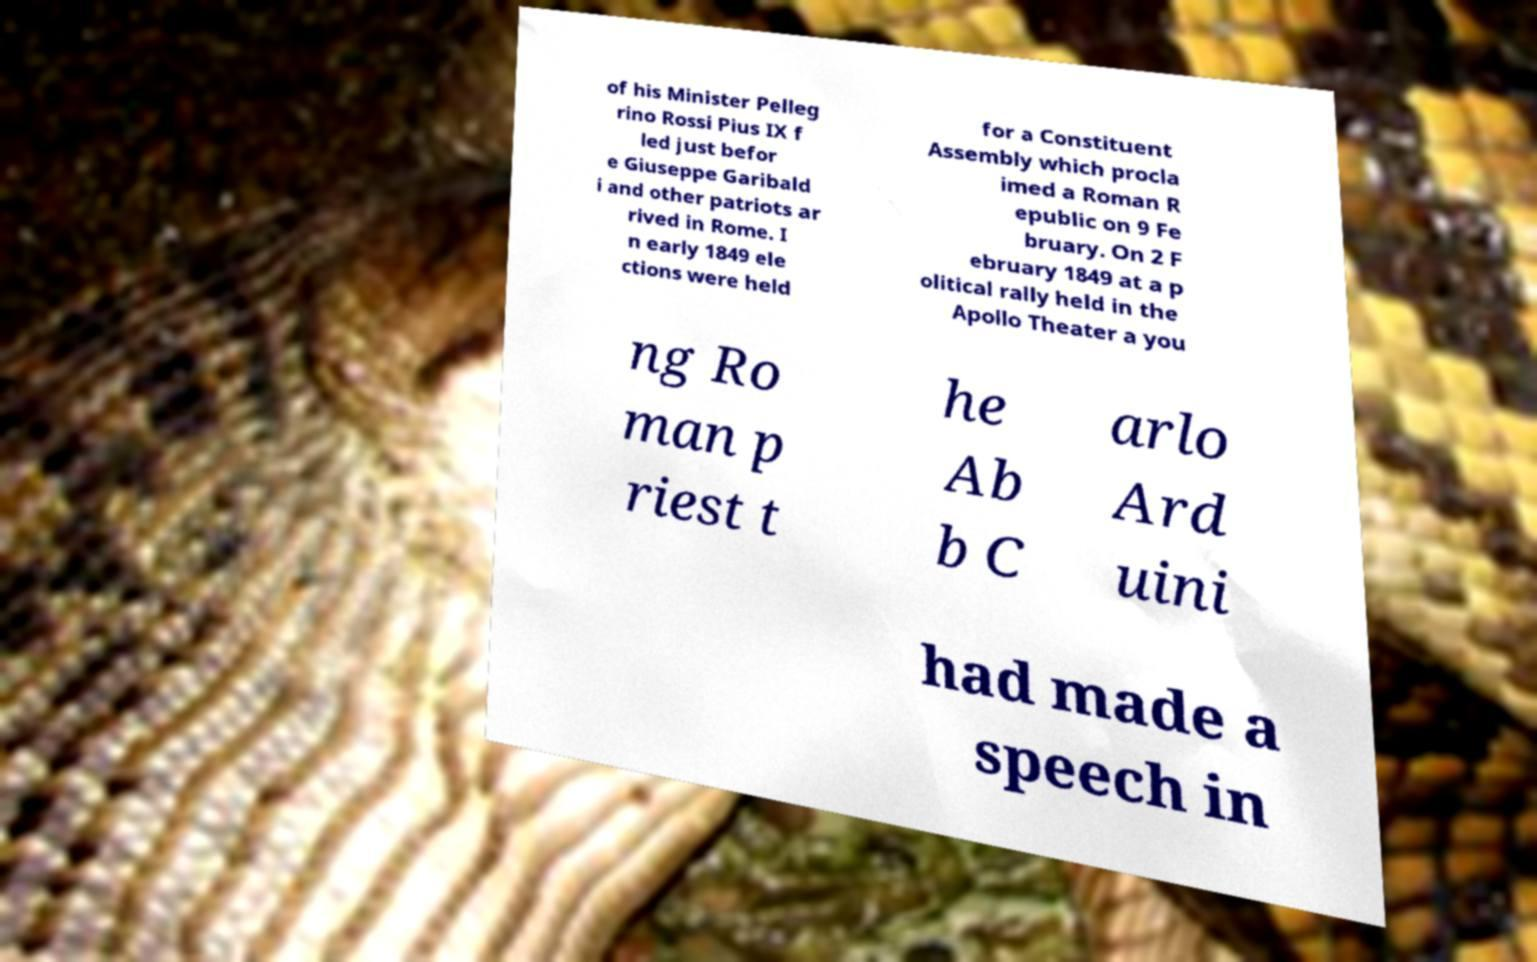I need the written content from this picture converted into text. Can you do that? of his Minister Pelleg rino Rossi Pius IX f led just befor e Giuseppe Garibald i and other patriots ar rived in Rome. I n early 1849 ele ctions were held for a Constituent Assembly which procla imed a Roman R epublic on 9 Fe bruary. On 2 F ebruary 1849 at a p olitical rally held in the Apollo Theater a you ng Ro man p riest t he Ab b C arlo Ard uini had made a speech in 